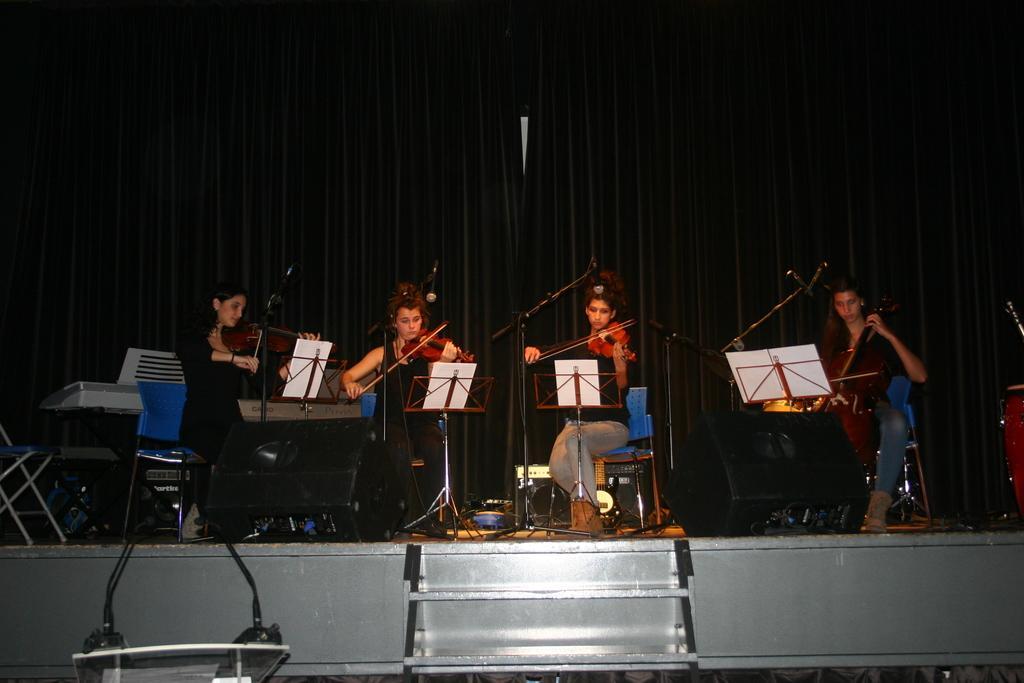In one or two sentences, can you explain what this image depicts? Here we can see a group of persons sitting on the chair, and playing violin, and in front here is the book, and here is the staircase. 